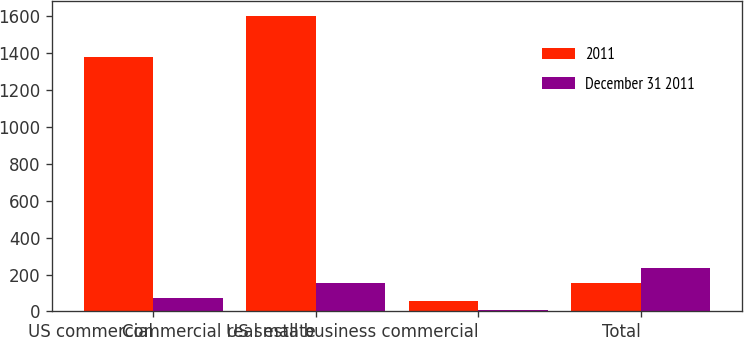Convert chart. <chart><loc_0><loc_0><loc_500><loc_500><stacked_bar_chart><ecel><fcel>US commercial<fcel>Commercial real estate<fcel>US small business commercial<fcel>Total<nl><fcel>2011<fcel>1381<fcel>1604<fcel>58<fcel>152<nl><fcel>December 31 2011<fcel>74<fcel>152<fcel>10<fcel>236<nl></chart> 